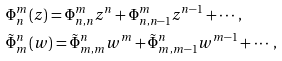Convert formula to latex. <formula><loc_0><loc_0><loc_500><loc_500>& \Phi _ { n } ^ { m } ( z ) = \Phi ^ { m } _ { n , n } z ^ { n } + \Phi ^ { m } _ { n , n - 1 } z ^ { n - 1 } + \cdots , \\ & \tilde { \Phi } _ { m } ^ { n } ( w ) = \tilde { \Phi } ^ { n } _ { m , m } w ^ { m } + \tilde { \Phi } ^ { n } _ { m , m - 1 } w ^ { m - 1 } + \cdots ,</formula> 